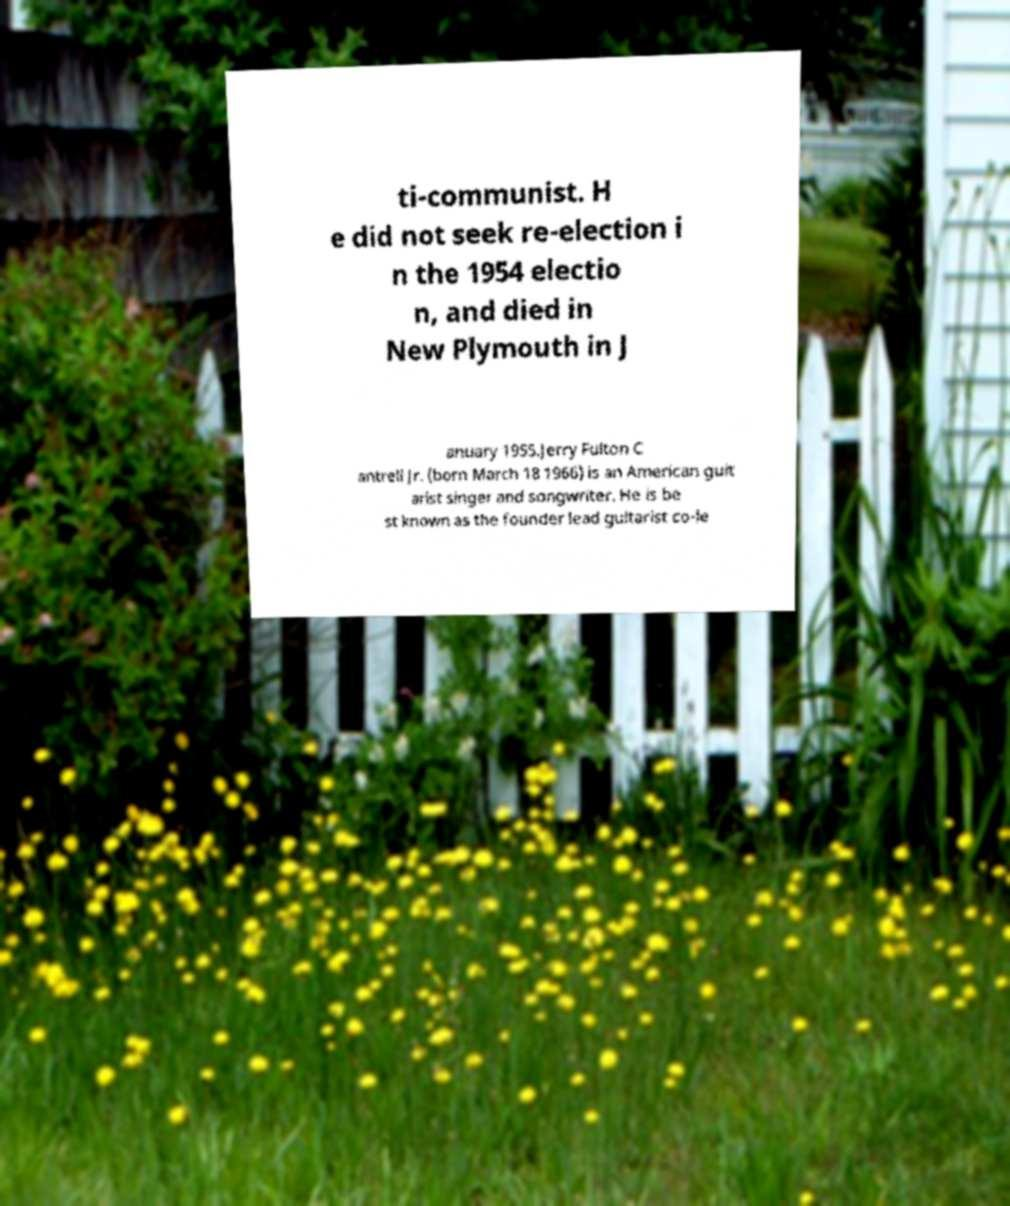What messages or text are displayed in this image? I need them in a readable, typed format. ti-communist. H e did not seek re-election i n the 1954 electio n, and died in New Plymouth in J anuary 1955.Jerry Fulton C antrell Jr. (born March 18 1966) is an American guit arist singer and songwriter. He is be st known as the founder lead guitarist co-le 